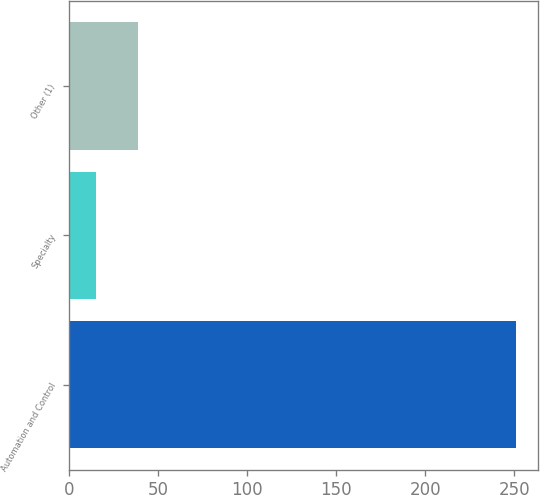Convert chart. <chart><loc_0><loc_0><loc_500><loc_500><bar_chart><fcel>Automation and Control<fcel>Specialty<fcel>Other (1)<nl><fcel>251<fcel>15<fcel>38.6<nl></chart> 